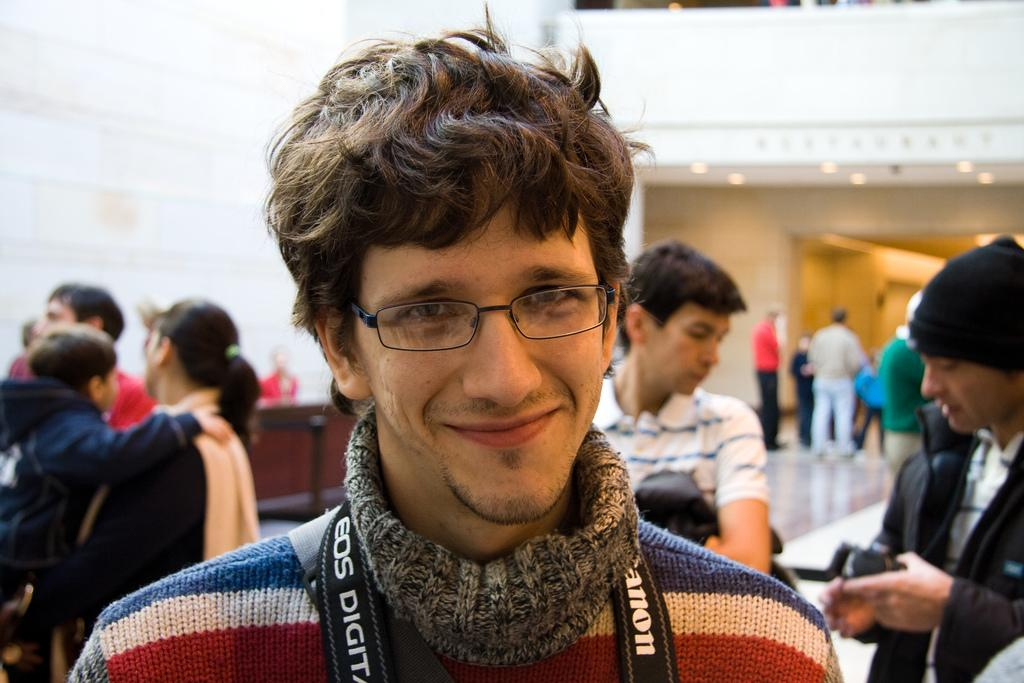What can be seen in the image? There are persons standing in the image. Where are the persons standing? The persons are standing on the floor. What type of lighting is present in the image? There are electric lights in the image. What type of magic is being performed by the persons in the image? There is no indication of magic or any magical activity in the image. 